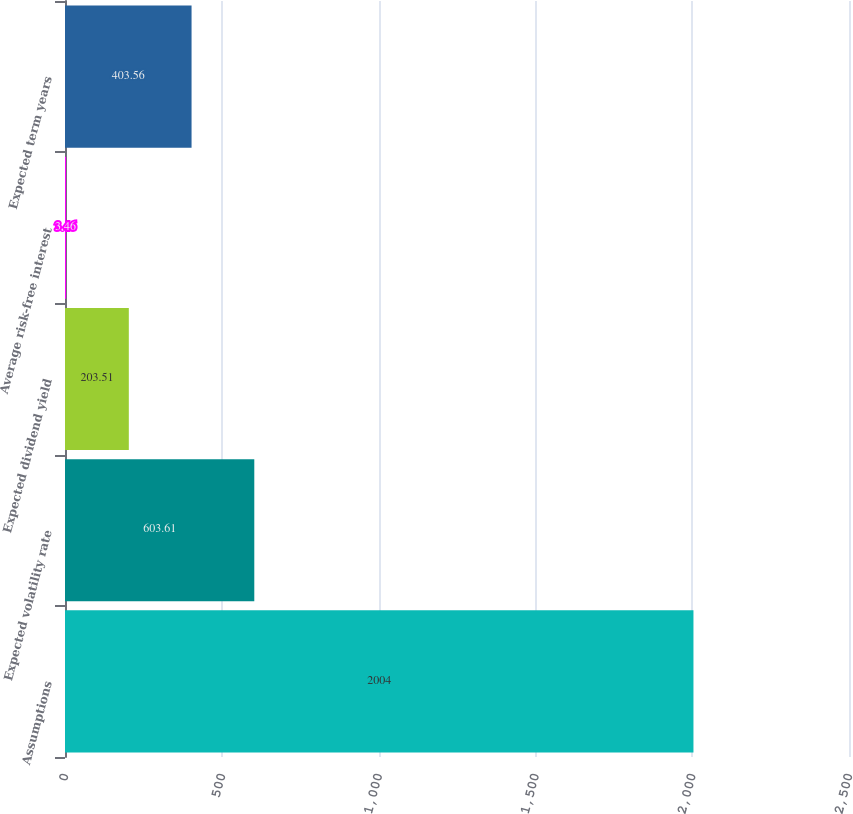Convert chart to OTSL. <chart><loc_0><loc_0><loc_500><loc_500><bar_chart><fcel>Assumptions<fcel>Expected volatility rate<fcel>Expected dividend yield<fcel>Average risk-free interest<fcel>Expected term years<nl><fcel>2004<fcel>603.61<fcel>203.51<fcel>3.46<fcel>403.56<nl></chart> 